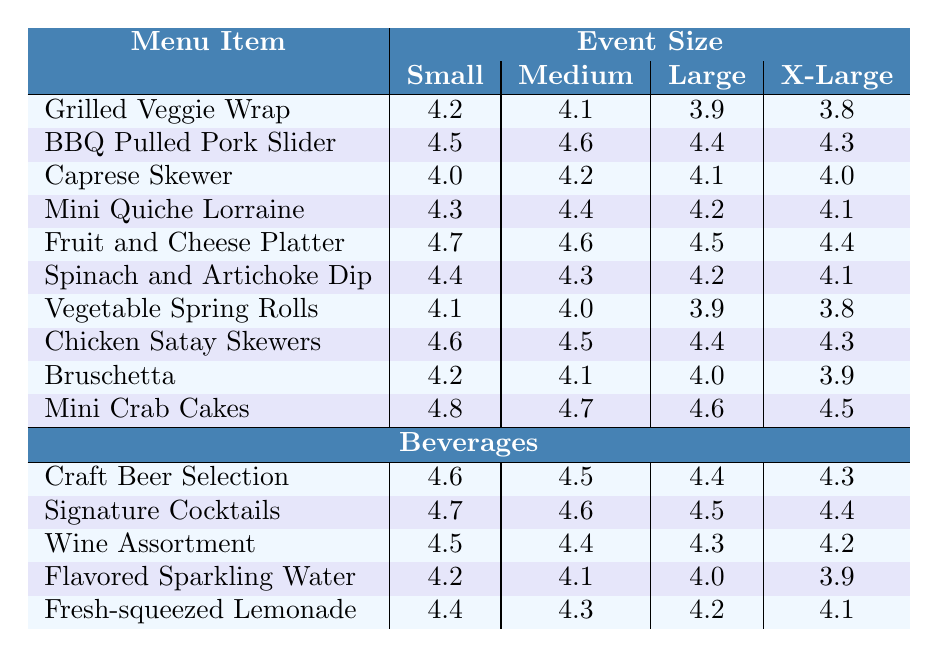What is the satisfaction rating for the BBQ Pulled Pork Slider at medium-sized events? The table shows that the satisfaction rating for the BBQ Pulled Pork Slider in medium-sized events is 4.6.
Answer: 4.6 Which menu item has the highest satisfaction rating at small events? By checking the ratings for small events, the Fruit and Cheese Platter has the highest rating of 4.7 among all menu items.
Answer: Fruit and Cheese Platter What is the average satisfaction rating for Mini Crab Cakes across all event sizes? The ratings for Mini Crab Cakes are 4.8, 4.7, 4.6, and 4.5. Adding these yields 18.6, and dividing by 4 gives an average rating of 4.65.
Answer: 4.65 Are the satisfaction ratings for the Vegetable Spring Rolls consistently below 4.0 at any event size? The ratings for Vegetable Spring Rolls are 4.1, 4.0, 3.9, and 3.8. The ratings were below 4.0 at large and X-Large event sizes (3.9 and 3.8).
Answer: Yes What is the difference in satisfaction ratings between the Chicken Satay Skewers and Mini Quiche Lorraine at large event sizes? The satisfaction rating for Chicken Satay Skewers is 4.4, and for Mini Quiche Lorraine, it is 4.2. The difference is 4.4 - 4.2 = 0.2.
Answer: 0.2 Which beverage has the lowest satisfaction rating at X-Large events? The table shows the satisfaction ratings for beverages at X-Large events. The Flavored Sparkling Water has the lowest rating of 3.9.
Answer: Flavored Sparkling Water Is the satisfaction rating for the Signature Cocktails higher than that for the Craft Beer Selection at medium-sized events? The rating for Signature Cocktails at medium-sized events is 4.6, while for Craft Beer Selection it is 4.5. Since 4.6 is greater than 4.5, this statement is true.
Answer: Yes What is the total satisfaction rating for Grilled Veggie Wrap at all event sizes combined? The ratings for Grilled Veggie Wrap are 4.2, 4.1, 3.9, and 3.8. Adding these ratings gives a total of 16.0.
Answer: 16.0 Which menu item shows the most significant drop in satisfaction from small to X-Large events? The satisfaction rating for Grilled Veggie Wrap drops from 4.2 to 3.8, a decrease of 0.4; Vegetable Spring Rolls drops from 4.1 to 3.8, a decrease of 0.3; but the Grilled Veggie Wrap has more significant drop of 0.4.
Answer: Grilled Veggie Wrap What is the median satisfaction rating for all menu items at large events? The ratings at large events are: 3.8 (Grilled Veggie Wrap), 4.4 (BBQ Pulled Pork Slider), 4.1 (Caprese Skewer), 4.2 (Mini Quiche Lorraine), 4.5 (Fruit and Cheese Platter), 4.2 (Spinach and Artichoke Dip), 3.9 (Vegetable Spring Rolls), 4.4 (Chicken Satay Skewers), 4.0 (Bruschetta), 4.6 (Mini Crab Cakes). Sorting these values gives 3.8, 3.9, 4.0, 4.1, 4.2, 4.2, 4.4, 4.4, 4.5, 4.6. The median is the average of 4.2 and 4.4, yielding 4.3.
Answer: 4.3 